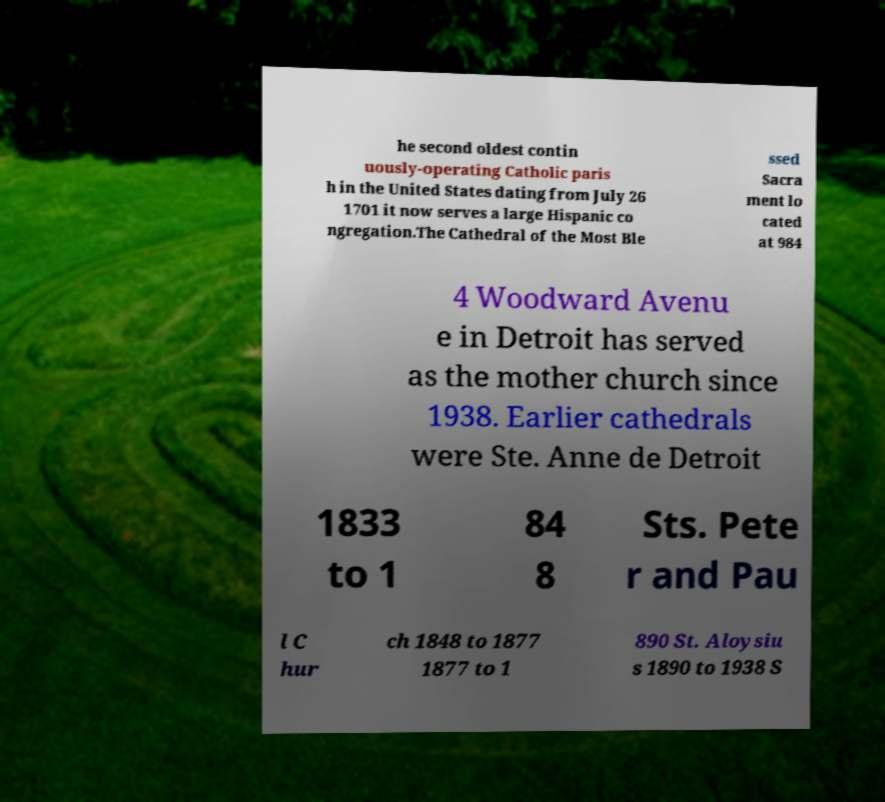Could you extract and type out the text from this image? he second oldest contin uously-operating Catholic paris h in the United States dating from July 26 1701 it now serves a large Hispanic co ngregation.The Cathedral of the Most Ble ssed Sacra ment lo cated at 984 4 Woodward Avenu e in Detroit has served as the mother church since 1938. Earlier cathedrals were Ste. Anne de Detroit 1833 to 1 84 8 Sts. Pete r and Pau l C hur ch 1848 to 1877 1877 to 1 890 St. Aloysiu s 1890 to 1938 S 